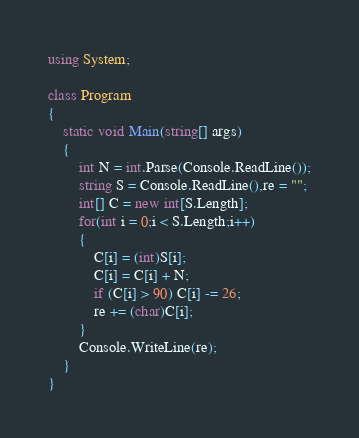Convert code to text. <code><loc_0><loc_0><loc_500><loc_500><_C#_>using System;

class Program
{
	static void Main(string[] args)
	{
		int N = int.Parse(Console.ReadLine());
		string S = Console.ReadLine(),re = "";
		int[] C = new int[S.Length];
		for(int i = 0;i < S.Length;i++)
		{
			C[i] = (int)S[i];
			C[i] = C[i] + N;
			if (C[i] > 90) C[i] -= 26;
			re += (char)C[i];
		}
		Console.WriteLine(re);
	}
}
</code> 